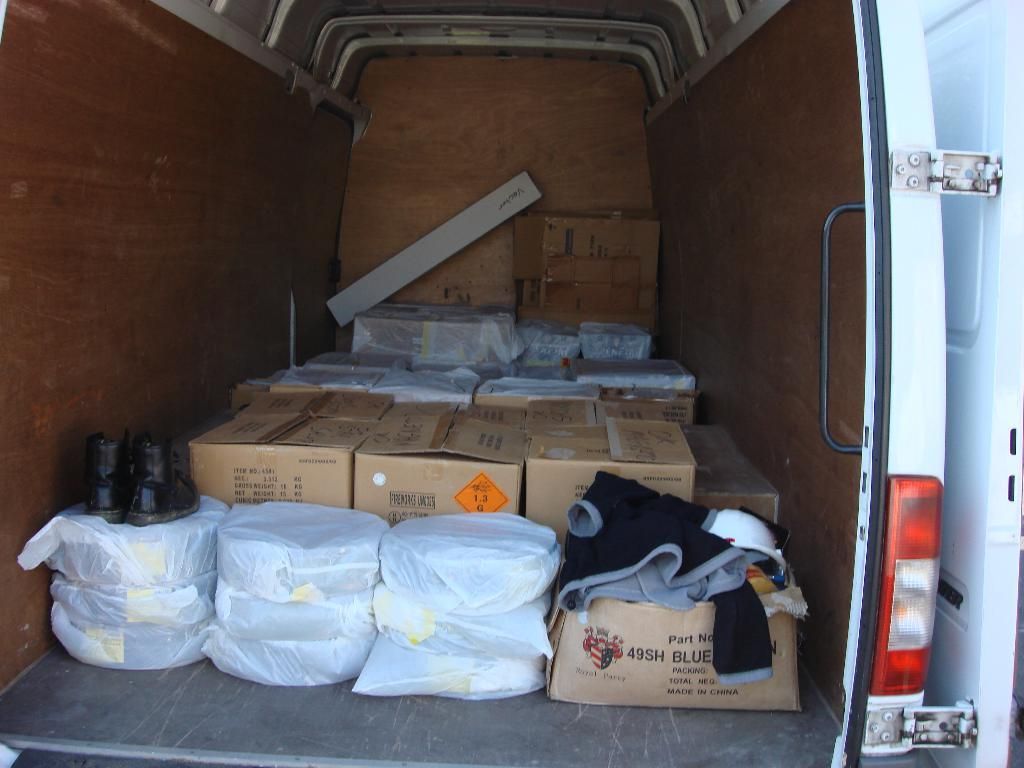What is the main object in the image? There is a vehicle in the image. What items can be seen inside the vehicle? There are boxes, covers, shoes, and a cloth in the vehicle. How many hands are visible in the image? There are no hands visible in the image. What type of pain is being experienced by the objects in the image? There is no indication of pain in the image, as it features inanimate objects like a vehicle, boxes, covers, shoes, and a cloth. 